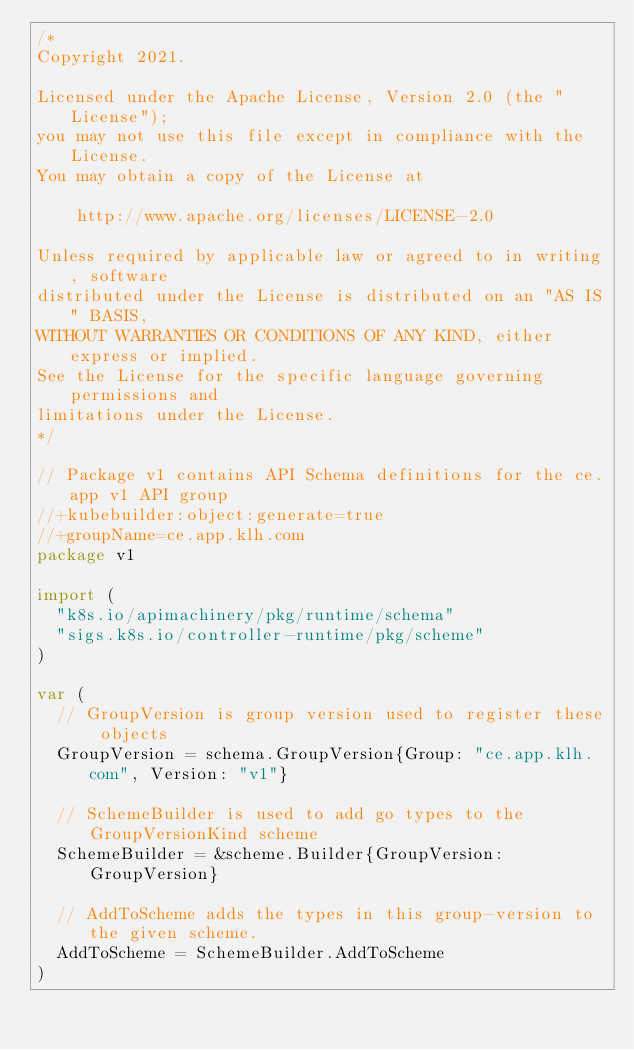<code> <loc_0><loc_0><loc_500><loc_500><_Go_>/*
Copyright 2021.

Licensed under the Apache License, Version 2.0 (the "License");
you may not use this file except in compliance with the License.
You may obtain a copy of the License at

    http://www.apache.org/licenses/LICENSE-2.0

Unless required by applicable law or agreed to in writing, software
distributed under the License is distributed on an "AS IS" BASIS,
WITHOUT WARRANTIES OR CONDITIONS OF ANY KIND, either express or implied.
See the License for the specific language governing permissions and
limitations under the License.
*/

// Package v1 contains API Schema definitions for the ce.app v1 API group
//+kubebuilder:object:generate=true
//+groupName=ce.app.klh.com
package v1

import (
	"k8s.io/apimachinery/pkg/runtime/schema"
	"sigs.k8s.io/controller-runtime/pkg/scheme"
)

var (
	// GroupVersion is group version used to register these objects
	GroupVersion = schema.GroupVersion{Group: "ce.app.klh.com", Version: "v1"}

	// SchemeBuilder is used to add go types to the GroupVersionKind scheme
	SchemeBuilder = &scheme.Builder{GroupVersion: GroupVersion}

	// AddToScheme adds the types in this group-version to the given scheme.
	AddToScheme = SchemeBuilder.AddToScheme
)
</code> 